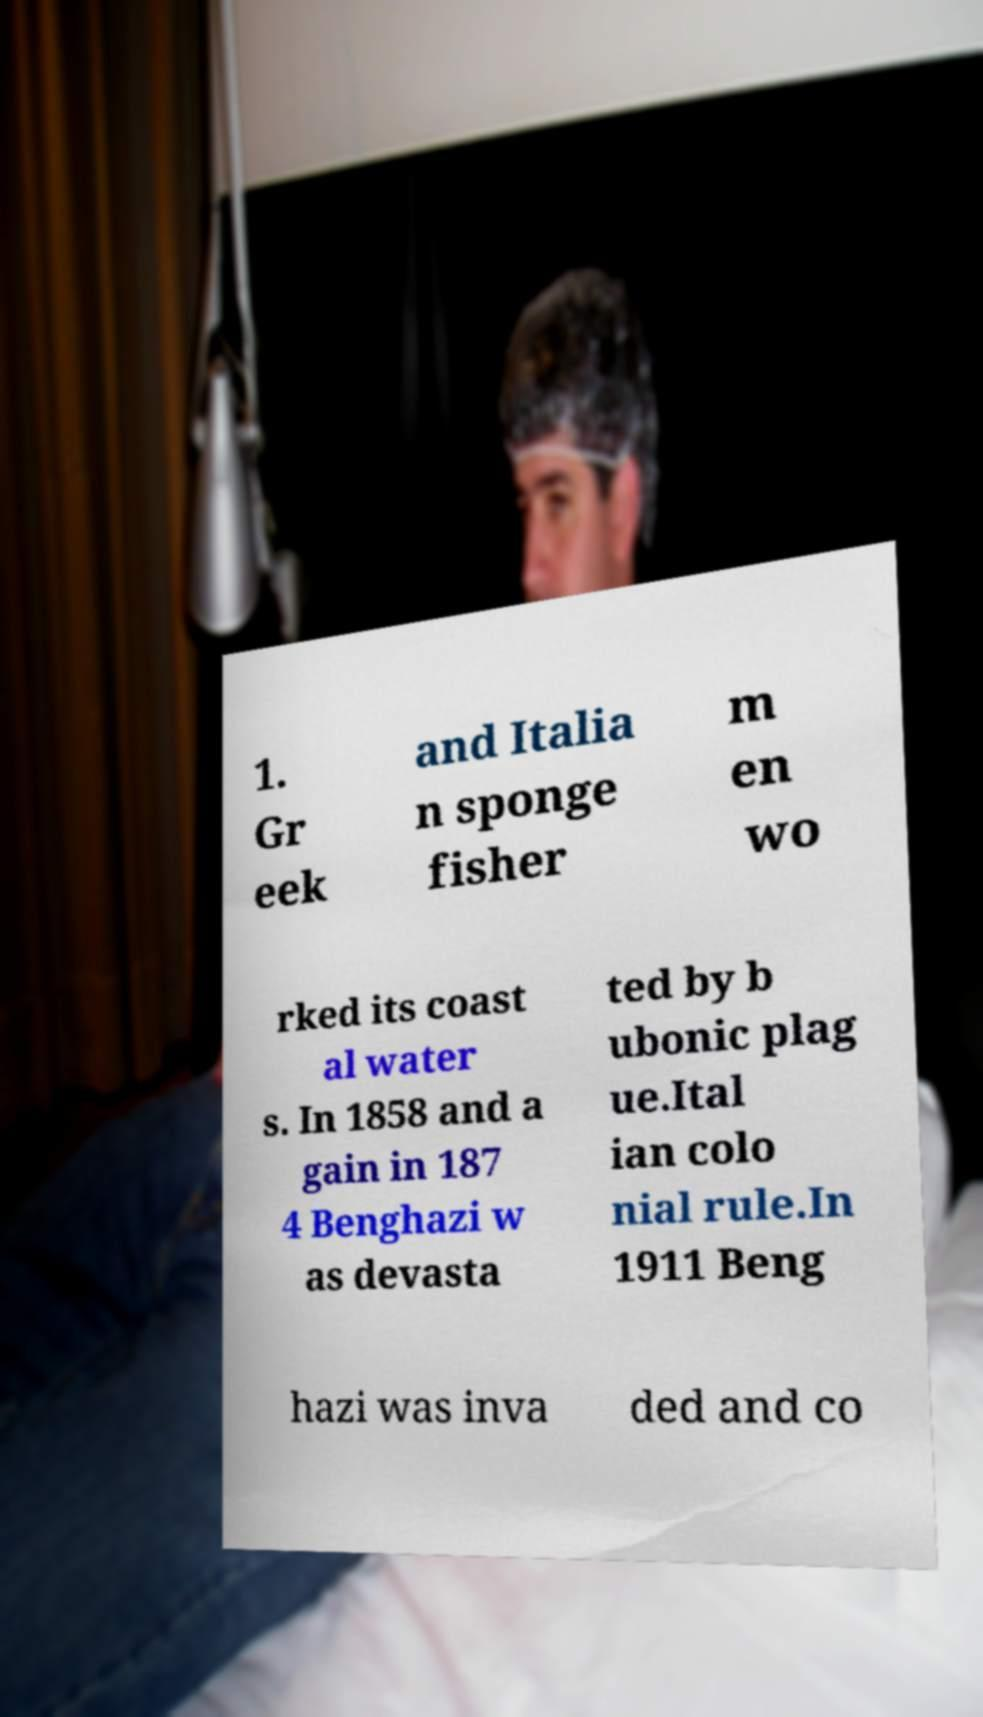I need the written content from this picture converted into text. Can you do that? 1. Gr eek and Italia n sponge fisher m en wo rked its coast al water s. In 1858 and a gain in 187 4 Benghazi w as devasta ted by b ubonic plag ue.Ital ian colo nial rule.In 1911 Beng hazi was inva ded and co 